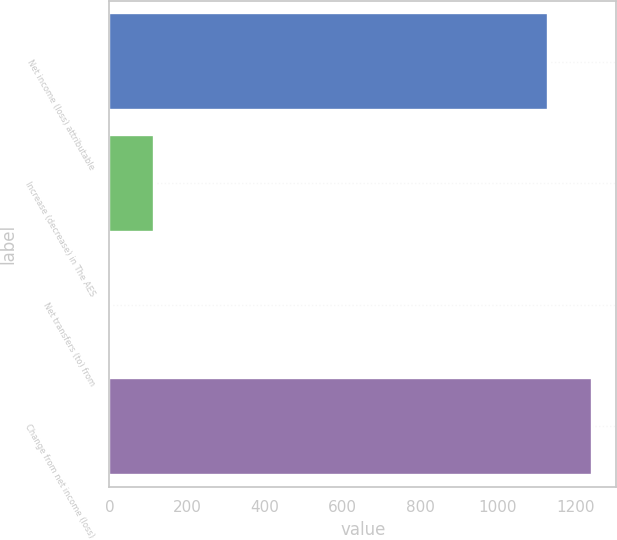<chart> <loc_0><loc_0><loc_500><loc_500><bar_chart><fcel>Net income (loss) attributable<fcel>Increase (decrease) in The AES<fcel>Net transfers (to) from<fcel>Change from net income (loss)<nl><fcel>1130<fcel>115<fcel>2<fcel>1243<nl></chart> 